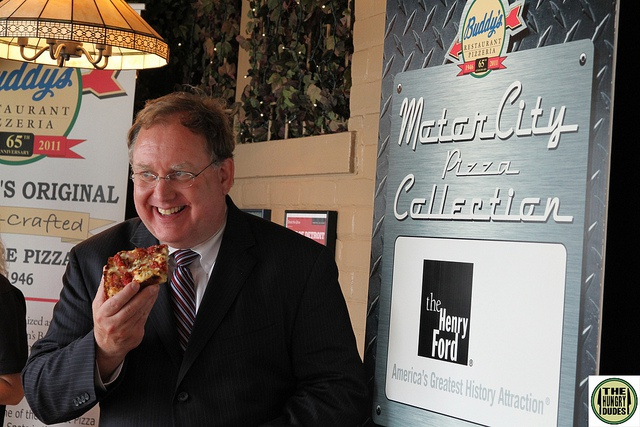Describe the objects in this image and their specific colors. I can see people in black, maroon, brown, and gray tones, people in black, maroon, darkgray, and gray tones, pizza in black, maroon, and brown tones, and tie in black, gray, and maroon tones in this image. 